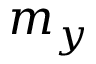Convert formula to latex. <formula><loc_0><loc_0><loc_500><loc_500>m _ { y }</formula> 